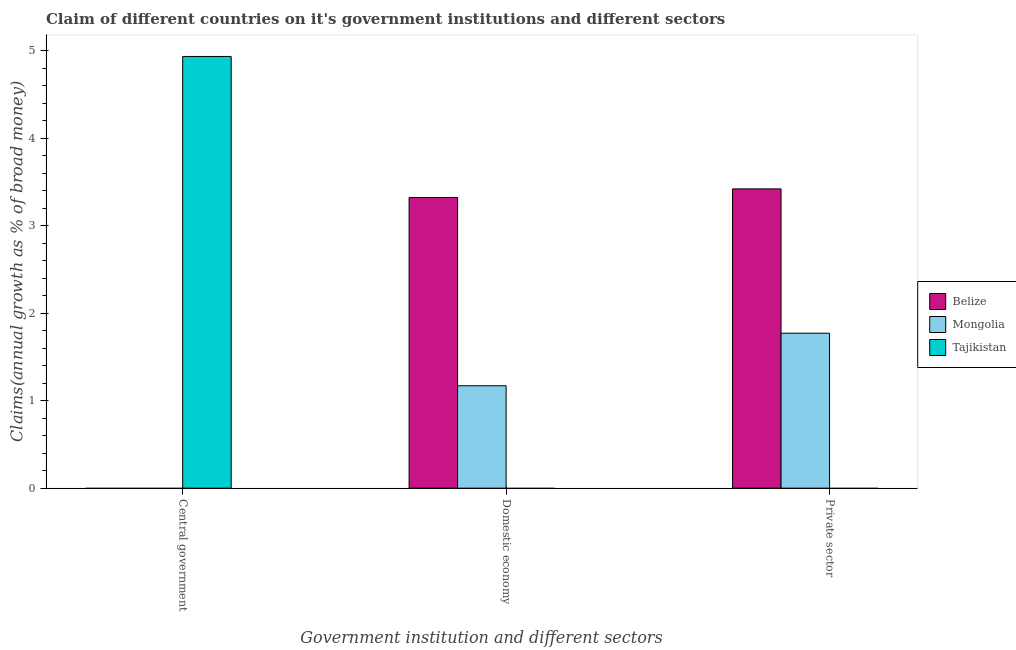How many different coloured bars are there?
Your response must be concise. 3. How many bars are there on the 3rd tick from the left?
Give a very brief answer. 2. What is the label of the 3rd group of bars from the left?
Your answer should be very brief. Private sector. What is the percentage of claim on the central government in Belize?
Your response must be concise. 0. Across all countries, what is the maximum percentage of claim on the central government?
Offer a very short reply. 4.93. In which country was the percentage of claim on the private sector maximum?
Your response must be concise. Belize. What is the total percentage of claim on the central government in the graph?
Keep it short and to the point. 4.93. What is the difference between the percentage of claim on the private sector in Belize and that in Mongolia?
Ensure brevity in your answer.  1.65. What is the difference between the percentage of claim on the private sector in Mongolia and the percentage of claim on the domestic economy in Belize?
Provide a succinct answer. -1.55. What is the average percentage of claim on the central government per country?
Give a very brief answer. 1.64. What is the difference between the percentage of claim on the domestic economy and percentage of claim on the private sector in Belize?
Provide a succinct answer. -0.1. In how many countries, is the percentage of claim on the domestic economy greater than 4 %?
Give a very brief answer. 0. What is the difference between the highest and the lowest percentage of claim on the domestic economy?
Your answer should be compact. 3.32. In how many countries, is the percentage of claim on the central government greater than the average percentage of claim on the central government taken over all countries?
Your response must be concise. 1. Is it the case that in every country, the sum of the percentage of claim on the central government and percentage of claim on the domestic economy is greater than the percentage of claim on the private sector?
Give a very brief answer. No. How many bars are there?
Make the answer very short. 5. Are all the bars in the graph horizontal?
Offer a terse response. No. How many countries are there in the graph?
Your answer should be very brief. 3. Are the values on the major ticks of Y-axis written in scientific E-notation?
Your response must be concise. No. Does the graph contain any zero values?
Give a very brief answer. Yes. How are the legend labels stacked?
Offer a very short reply. Vertical. What is the title of the graph?
Your answer should be compact. Claim of different countries on it's government institutions and different sectors. Does "Bahrain" appear as one of the legend labels in the graph?
Keep it short and to the point. No. What is the label or title of the X-axis?
Provide a short and direct response. Government institution and different sectors. What is the label or title of the Y-axis?
Your answer should be very brief. Claims(annual growth as % of broad money). What is the Claims(annual growth as % of broad money) in Tajikistan in Central government?
Offer a terse response. 4.93. What is the Claims(annual growth as % of broad money) in Belize in Domestic economy?
Make the answer very short. 3.32. What is the Claims(annual growth as % of broad money) of Mongolia in Domestic economy?
Provide a succinct answer. 1.17. What is the Claims(annual growth as % of broad money) in Tajikistan in Domestic economy?
Provide a succinct answer. 0. What is the Claims(annual growth as % of broad money) of Belize in Private sector?
Offer a very short reply. 3.42. What is the Claims(annual growth as % of broad money) of Mongolia in Private sector?
Provide a short and direct response. 1.77. Across all Government institution and different sectors, what is the maximum Claims(annual growth as % of broad money) of Belize?
Provide a succinct answer. 3.42. Across all Government institution and different sectors, what is the maximum Claims(annual growth as % of broad money) in Mongolia?
Provide a succinct answer. 1.77. Across all Government institution and different sectors, what is the maximum Claims(annual growth as % of broad money) of Tajikistan?
Your answer should be very brief. 4.93. Across all Government institution and different sectors, what is the minimum Claims(annual growth as % of broad money) of Mongolia?
Your response must be concise. 0. Across all Government institution and different sectors, what is the minimum Claims(annual growth as % of broad money) in Tajikistan?
Provide a short and direct response. 0. What is the total Claims(annual growth as % of broad money) of Belize in the graph?
Your response must be concise. 6.74. What is the total Claims(annual growth as % of broad money) in Mongolia in the graph?
Provide a short and direct response. 2.94. What is the total Claims(annual growth as % of broad money) in Tajikistan in the graph?
Provide a succinct answer. 4.93. What is the difference between the Claims(annual growth as % of broad money) in Belize in Domestic economy and that in Private sector?
Offer a terse response. -0.1. What is the difference between the Claims(annual growth as % of broad money) of Mongolia in Domestic economy and that in Private sector?
Make the answer very short. -0.6. What is the difference between the Claims(annual growth as % of broad money) of Belize in Domestic economy and the Claims(annual growth as % of broad money) of Mongolia in Private sector?
Your answer should be very brief. 1.55. What is the average Claims(annual growth as % of broad money) in Belize per Government institution and different sectors?
Your answer should be very brief. 2.25. What is the average Claims(annual growth as % of broad money) of Mongolia per Government institution and different sectors?
Your answer should be compact. 0.98. What is the average Claims(annual growth as % of broad money) in Tajikistan per Government institution and different sectors?
Provide a succinct answer. 1.64. What is the difference between the Claims(annual growth as % of broad money) in Belize and Claims(annual growth as % of broad money) in Mongolia in Domestic economy?
Provide a short and direct response. 2.15. What is the difference between the Claims(annual growth as % of broad money) of Belize and Claims(annual growth as % of broad money) of Mongolia in Private sector?
Offer a very short reply. 1.65. What is the ratio of the Claims(annual growth as % of broad money) of Belize in Domestic economy to that in Private sector?
Your answer should be compact. 0.97. What is the ratio of the Claims(annual growth as % of broad money) of Mongolia in Domestic economy to that in Private sector?
Make the answer very short. 0.66. What is the difference between the highest and the lowest Claims(annual growth as % of broad money) of Belize?
Your response must be concise. 3.42. What is the difference between the highest and the lowest Claims(annual growth as % of broad money) of Mongolia?
Provide a succinct answer. 1.77. What is the difference between the highest and the lowest Claims(annual growth as % of broad money) in Tajikistan?
Your answer should be compact. 4.93. 